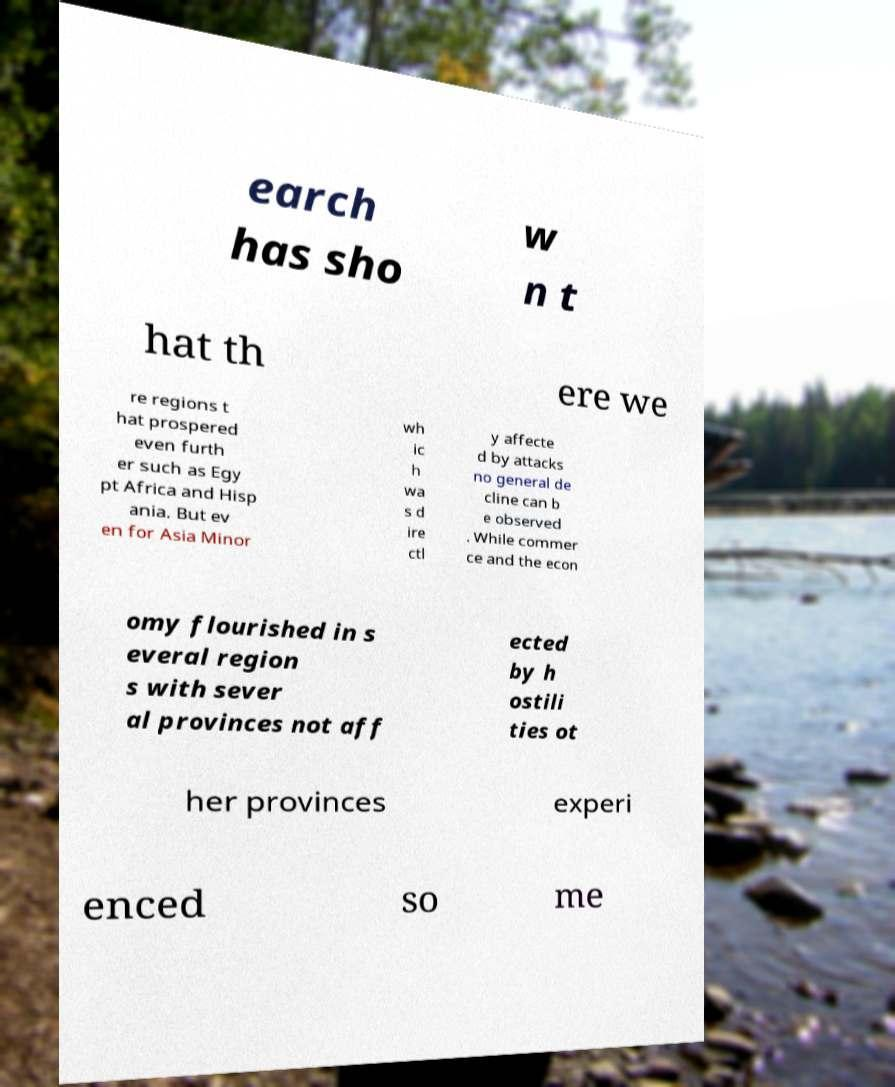What messages or text are displayed in this image? I need them in a readable, typed format. earch has sho w n t hat th ere we re regions t hat prospered even furth er such as Egy pt Africa and Hisp ania. But ev en for Asia Minor wh ic h wa s d ire ctl y affecte d by attacks no general de cline can b e observed . While commer ce and the econ omy flourished in s everal region s with sever al provinces not aff ected by h ostili ties ot her provinces experi enced so me 